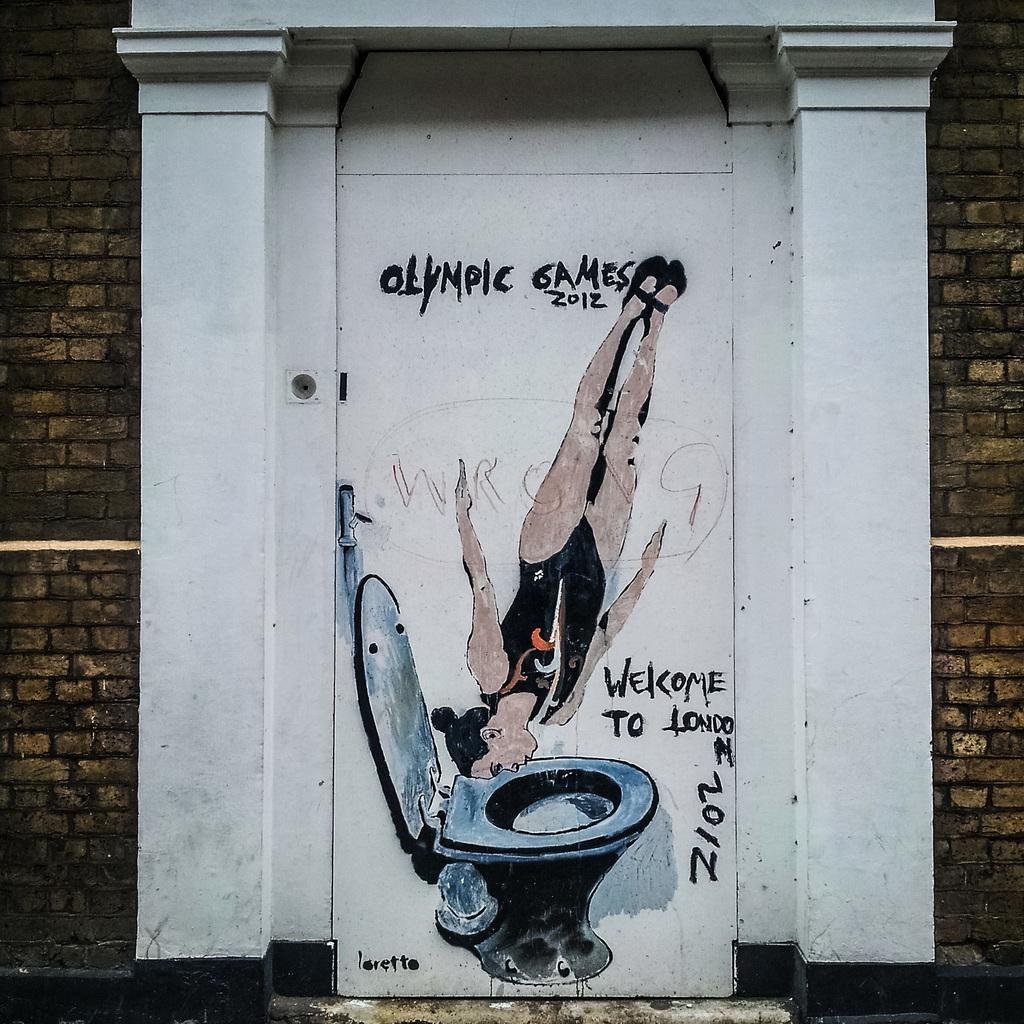<image>
Relay a brief, clear account of the picture shown. A drawing shows a swimmer diving into a toilet at the London games. 